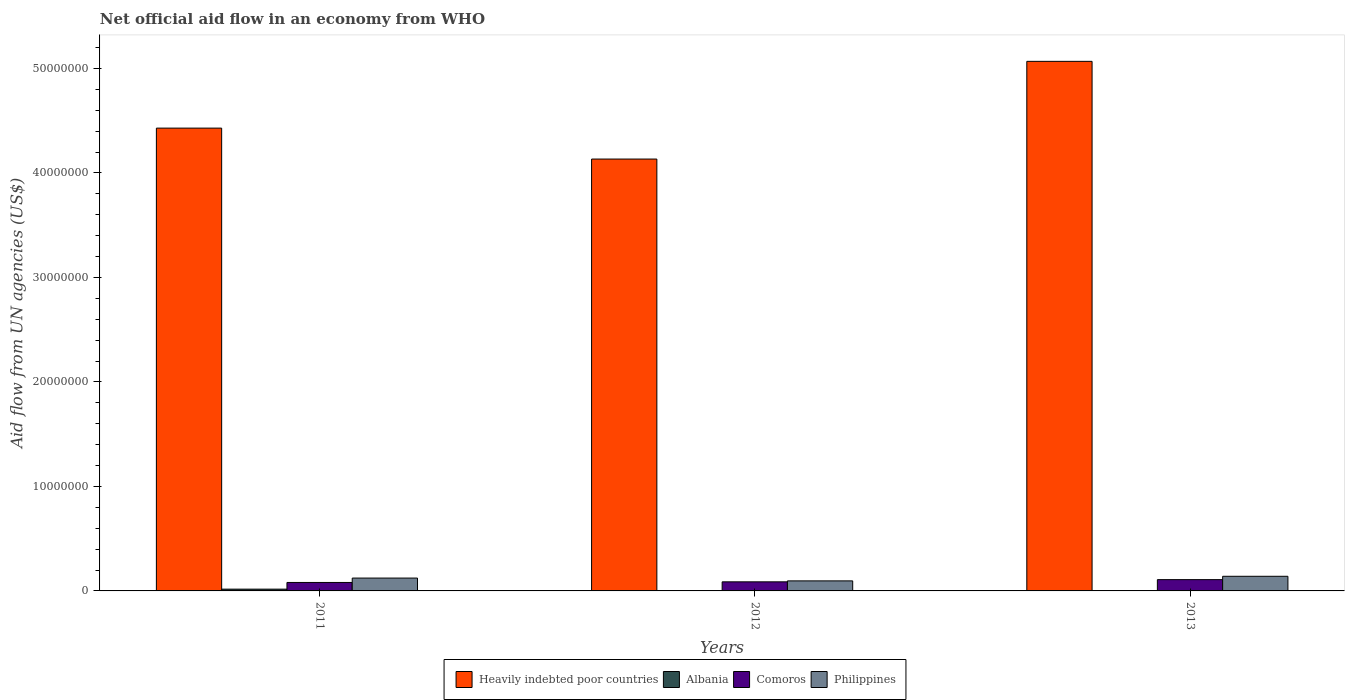How many different coloured bars are there?
Offer a very short reply. 4. How many groups of bars are there?
Offer a very short reply. 3. Are the number of bars on each tick of the X-axis equal?
Keep it short and to the point. Yes. How many bars are there on the 1st tick from the left?
Provide a short and direct response. 4. What is the label of the 3rd group of bars from the left?
Provide a short and direct response. 2013. What is the net official aid flow in Heavily indebted poor countries in 2013?
Offer a terse response. 5.07e+07. Across all years, what is the maximum net official aid flow in Heavily indebted poor countries?
Keep it short and to the point. 5.07e+07. Across all years, what is the minimum net official aid flow in Albania?
Offer a very short reply. 10000. In which year was the net official aid flow in Philippines maximum?
Provide a succinct answer. 2013. In which year was the net official aid flow in Albania minimum?
Provide a succinct answer. 2012. What is the total net official aid flow in Heavily indebted poor countries in the graph?
Offer a very short reply. 1.36e+08. What is the difference between the net official aid flow in Albania in 2011 and that in 2012?
Give a very brief answer. 1.60e+05. What is the difference between the net official aid flow in Heavily indebted poor countries in 2011 and the net official aid flow in Albania in 2013?
Your answer should be very brief. 4.43e+07. What is the average net official aid flow in Philippines per year?
Your response must be concise. 1.20e+06. In the year 2012, what is the difference between the net official aid flow in Heavily indebted poor countries and net official aid flow in Philippines?
Your answer should be very brief. 4.04e+07. In how many years, is the net official aid flow in Philippines greater than 26000000 US$?
Your answer should be very brief. 0. What is the ratio of the net official aid flow in Comoros in 2011 to that in 2013?
Keep it short and to the point. 0.75. What is the difference between the highest and the lowest net official aid flow in Comoros?
Ensure brevity in your answer.  2.70e+05. What does the 4th bar from the left in 2012 represents?
Make the answer very short. Philippines. What does the 2nd bar from the right in 2011 represents?
Your answer should be very brief. Comoros. How many bars are there?
Your answer should be compact. 12. What is the difference between two consecutive major ticks on the Y-axis?
Ensure brevity in your answer.  1.00e+07. Are the values on the major ticks of Y-axis written in scientific E-notation?
Give a very brief answer. No. Does the graph contain any zero values?
Give a very brief answer. No. Where does the legend appear in the graph?
Offer a very short reply. Bottom center. How are the legend labels stacked?
Offer a very short reply. Horizontal. What is the title of the graph?
Keep it short and to the point. Net official aid flow in an economy from WHO. What is the label or title of the Y-axis?
Offer a terse response. Aid flow from UN agencies (US$). What is the Aid flow from UN agencies (US$) of Heavily indebted poor countries in 2011?
Give a very brief answer. 4.43e+07. What is the Aid flow from UN agencies (US$) of Comoros in 2011?
Your answer should be very brief. 8.10e+05. What is the Aid flow from UN agencies (US$) in Philippines in 2011?
Provide a succinct answer. 1.23e+06. What is the Aid flow from UN agencies (US$) in Heavily indebted poor countries in 2012?
Keep it short and to the point. 4.13e+07. What is the Aid flow from UN agencies (US$) of Comoros in 2012?
Your response must be concise. 8.70e+05. What is the Aid flow from UN agencies (US$) of Philippines in 2012?
Make the answer very short. 9.60e+05. What is the Aid flow from UN agencies (US$) of Heavily indebted poor countries in 2013?
Ensure brevity in your answer.  5.07e+07. What is the Aid flow from UN agencies (US$) of Albania in 2013?
Your answer should be very brief. 3.00e+04. What is the Aid flow from UN agencies (US$) of Comoros in 2013?
Your answer should be compact. 1.08e+06. What is the Aid flow from UN agencies (US$) of Philippines in 2013?
Provide a succinct answer. 1.40e+06. Across all years, what is the maximum Aid flow from UN agencies (US$) in Heavily indebted poor countries?
Provide a succinct answer. 5.07e+07. Across all years, what is the maximum Aid flow from UN agencies (US$) of Albania?
Make the answer very short. 1.70e+05. Across all years, what is the maximum Aid flow from UN agencies (US$) in Comoros?
Ensure brevity in your answer.  1.08e+06. Across all years, what is the maximum Aid flow from UN agencies (US$) in Philippines?
Ensure brevity in your answer.  1.40e+06. Across all years, what is the minimum Aid flow from UN agencies (US$) of Heavily indebted poor countries?
Offer a very short reply. 4.13e+07. Across all years, what is the minimum Aid flow from UN agencies (US$) in Comoros?
Offer a very short reply. 8.10e+05. Across all years, what is the minimum Aid flow from UN agencies (US$) of Philippines?
Offer a very short reply. 9.60e+05. What is the total Aid flow from UN agencies (US$) in Heavily indebted poor countries in the graph?
Your answer should be compact. 1.36e+08. What is the total Aid flow from UN agencies (US$) in Albania in the graph?
Keep it short and to the point. 2.10e+05. What is the total Aid flow from UN agencies (US$) in Comoros in the graph?
Make the answer very short. 2.76e+06. What is the total Aid flow from UN agencies (US$) of Philippines in the graph?
Offer a very short reply. 3.59e+06. What is the difference between the Aid flow from UN agencies (US$) of Heavily indebted poor countries in 2011 and that in 2012?
Provide a succinct answer. 2.96e+06. What is the difference between the Aid flow from UN agencies (US$) in Albania in 2011 and that in 2012?
Give a very brief answer. 1.60e+05. What is the difference between the Aid flow from UN agencies (US$) of Comoros in 2011 and that in 2012?
Give a very brief answer. -6.00e+04. What is the difference between the Aid flow from UN agencies (US$) of Heavily indebted poor countries in 2011 and that in 2013?
Offer a terse response. -6.39e+06. What is the difference between the Aid flow from UN agencies (US$) in Albania in 2011 and that in 2013?
Your answer should be very brief. 1.40e+05. What is the difference between the Aid flow from UN agencies (US$) in Heavily indebted poor countries in 2012 and that in 2013?
Offer a very short reply. -9.35e+06. What is the difference between the Aid flow from UN agencies (US$) in Albania in 2012 and that in 2013?
Keep it short and to the point. -2.00e+04. What is the difference between the Aid flow from UN agencies (US$) of Philippines in 2012 and that in 2013?
Offer a very short reply. -4.40e+05. What is the difference between the Aid flow from UN agencies (US$) of Heavily indebted poor countries in 2011 and the Aid flow from UN agencies (US$) of Albania in 2012?
Offer a very short reply. 4.43e+07. What is the difference between the Aid flow from UN agencies (US$) in Heavily indebted poor countries in 2011 and the Aid flow from UN agencies (US$) in Comoros in 2012?
Your answer should be very brief. 4.34e+07. What is the difference between the Aid flow from UN agencies (US$) of Heavily indebted poor countries in 2011 and the Aid flow from UN agencies (US$) of Philippines in 2012?
Keep it short and to the point. 4.33e+07. What is the difference between the Aid flow from UN agencies (US$) in Albania in 2011 and the Aid flow from UN agencies (US$) in Comoros in 2012?
Provide a short and direct response. -7.00e+05. What is the difference between the Aid flow from UN agencies (US$) of Albania in 2011 and the Aid flow from UN agencies (US$) of Philippines in 2012?
Your response must be concise. -7.90e+05. What is the difference between the Aid flow from UN agencies (US$) of Heavily indebted poor countries in 2011 and the Aid flow from UN agencies (US$) of Albania in 2013?
Provide a succinct answer. 4.43e+07. What is the difference between the Aid flow from UN agencies (US$) in Heavily indebted poor countries in 2011 and the Aid flow from UN agencies (US$) in Comoros in 2013?
Offer a very short reply. 4.32e+07. What is the difference between the Aid flow from UN agencies (US$) of Heavily indebted poor countries in 2011 and the Aid flow from UN agencies (US$) of Philippines in 2013?
Ensure brevity in your answer.  4.29e+07. What is the difference between the Aid flow from UN agencies (US$) of Albania in 2011 and the Aid flow from UN agencies (US$) of Comoros in 2013?
Your answer should be very brief. -9.10e+05. What is the difference between the Aid flow from UN agencies (US$) of Albania in 2011 and the Aid flow from UN agencies (US$) of Philippines in 2013?
Provide a short and direct response. -1.23e+06. What is the difference between the Aid flow from UN agencies (US$) in Comoros in 2011 and the Aid flow from UN agencies (US$) in Philippines in 2013?
Keep it short and to the point. -5.90e+05. What is the difference between the Aid flow from UN agencies (US$) in Heavily indebted poor countries in 2012 and the Aid flow from UN agencies (US$) in Albania in 2013?
Offer a terse response. 4.13e+07. What is the difference between the Aid flow from UN agencies (US$) of Heavily indebted poor countries in 2012 and the Aid flow from UN agencies (US$) of Comoros in 2013?
Offer a very short reply. 4.02e+07. What is the difference between the Aid flow from UN agencies (US$) in Heavily indebted poor countries in 2012 and the Aid flow from UN agencies (US$) in Philippines in 2013?
Offer a very short reply. 3.99e+07. What is the difference between the Aid flow from UN agencies (US$) in Albania in 2012 and the Aid flow from UN agencies (US$) in Comoros in 2013?
Ensure brevity in your answer.  -1.07e+06. What is the difference between the Aid flow from UN agencies (US$) of Albania in 2012 and the Aid flow from UN agencies (US$) of Philippines in 2013?
Provide a short and direct response. -1.39e+06. What is the difference between the Aid flow from UN agencies (US$) of Comoros in 2012 and the Aid flow from UN agencies (US$) of Philippines in 2013?
Ensure brevity in your answer.  -5.30e+05. What is the average Aid flow from UN agencies (US$) in Heavily indebted poor countries per year?
Make the answer very short. 4.54e+07. What is the average Aid flow from UN agencies (US$) of Albania per year?
Provide a short and direct response. 7.00e+04. What is the average Aid flow from UN agencies (US$) of Comoros per year?
Keep it short and to the point. 9.20e+05. What is the average Aid flow from UN agencies (US$) in Philippines per year?
Give a very brief answer. 1.20e+06. In the year 2011, what is the difference between the Aid flow from UN agencies (US$) of Heavily indebted poor countries and Aid flow from UN agencies (US$) of Albania?
Provide a short and direct response. 4.41e+07. In the year 2011, what is the difference between the Aid flow from UN agencies (US$) of Heavily indebted poor countries and Aid flow from UN agencies (US$) of Comoros?
Ensure brevity in your answer.  4.35e+07. In the year 2011, what is the difference between the Aid flow from UN agencies (US$) of Heavily indebted poor countries and Aid flow from UN agencies (US$) of Philippines?
Provide a short and direct response. 4.31e+07. In the year 2011, what is the difference between the Aid flow from UN agencies (US$) of Albania and Aid flow from UN agencies (US$) of Comoros?
Your response must be concise. -6.40e+05. In the year 2011, what is the difference between the Aid flow from UN agencies (US$) in Albania and Aid flow from UN agencies (US$) in Philippines?
Offer a very short reply. -1.06e+06. In the year 2011, what is the difference between the Aid flow from UN agencies (US$) in Comoros and Aid flow from UN agencies (US$) in Philippines?
Your answer should be very brief. -4.20e+05. In the year 2012, what is the difference between the Aid flow from UN agencies (US$) in Heavily indebted poor countries and Aid flow from UN agencies (US$) in Albania?
Keep it short and to the point. 4.13e+07. In the year 2012, what is the difference between the Aid flow from UN agencies (US$) in Heavily indebted poor countries and Aid flow from UN agencies (US$) in Comoros?
Provide a short and direct response. 4.05e+07. In the year 2012, what is the difference between the Aid flow from UN agencies (US$) in Heavily indebted poor countries and Aid flow from UN agencies (US$) in Philippines?
Ensure brevity in your answer.  4.04e+07. In the year 2012, what is the difference between the Aid flow from UN agencies (US$) of Albania and Aid flow from UN agencies (US$) of Comoros?
Give a very brief answer. -8.60e+05. In the year 2012, what is the difference between the Aid flow from UN agencies (US$) in Albania and Aid flow from UN agencies (US$) in Philippines?
Your answer should be compact. -9.50e+05. In the year 2012, what is the difference between the Aid flow from UN agencies (US$) of Comoros and Aid flow from UN agencies (US$) of Philippines?
Offer a very short reply. -9.00e+04. In the year 2013, what is the difference between the Aid flow from UN agencies (US$) of Heavily indebted poor countries and Aid flow from UN agencies (US$) of Albania?
Your answer should be very brief. 5.06e+07. In the year 2013, what is the difference between the Aid flow from UN agencies (US$) in Heavily indebted poor countries and Aid flow from UN agencies (US$) in Comoros?
Ensure brevity in your answer.  4.96e+07. In the year 2013, what is the difference between the Aid flow from UN agencies (US$) in Heavily indebted poor countries and Aid flow from UN agencies (US$) in Philippines?
Offer a terse response. 4.93e+07. In the year 2013, what is the difference between the Aid flow from UN agencies (US$) in Albania and Aid flow from UN agencies (US$) in Comoros?
Provide a short and direct response. -1.05e+06. In the year 2013, what is the difference between the Aid flow from UN agencies (US$) in Albania and Aid flow from UN agencies (US$) in Philippines?
Offer a terse response. -1.37e+06. In the year 2013, what is the difference between the Aid flow from UN agencies (US$) of Comoros and Aid flow from UN agencies (US$) of Philippines?
Make the answer very short. -3.20e+05. What is the ratio of the Aid flow from UN agencies (US$) in Heavily indebted poor countries in 2011 to that in 2012?
Keep it short and to the point. 1.07. What is the ratio of the Aid flow from UN agencies (US$) of Comoros in 2011 to that in 2012?
Your answer should be compact. 0.93. What is the ratio of the Aid flow from UN agencies (US$) in Philippines in 2011 to that in 2012?
Your response must be concise. 1.28. What is the ratio of the Aid flow from UN agencies (US$) in Heavily indebted poor countries in 2011 to that in 2013?
Your answer should be compact. 0.87. What is the ratio of the Aid flow from UN agencies (US$) of Albania in 2011 to that in 2013?
Offer a terse response. 5.67. What is the ratio of the Aid flow from UN agencies (US$) of Comoros in 2011 to that in 2013?
Offer a very short reply. 0.75. What is the ratio of the Aid flow from UN agencies (US$) of Philippines in 2011 to that in 2013?
Offer a terse response. 0.88. What is the ratio of the Aid flow from UN agencies (US$) of Heavily indebted poor countries in 2012 to that in 2013?
Your answer should be very brief. 0.82. What is the ratio of the Aid flow from UN agencies (US$) of Albania in 2012 to that in 2013?
Ensure brevity in your answer.  0.33. What is the ratio of the Aid flow from UN agencies (US$) in Comoros in 2012 to that in 2013?
Your answer should be compact. 0.81. What is the ratio of the Aid flow from UN agencies (US$) in Philippines in 2012 to that in 2013?
Keep it short and to the point. 0.69. What is the difference between the highest and the second highest Aid flow from UN agencies (US$) of Heavily indebted poor countries?
Offer a terse response. 6.39e+06. What is the difference between the highest and the second highest Aid flow from UN agencies (US$) of Albania?
Ensure brevity in your answer.  1.40e+05. What is the difference between the highest and the second highest Aid flow from UN agencies (US$) in Philippines?
Provide a short and direct response. 1.70e+05. What is the difference between the highest and the lowest Aid flow from UN agencies (US$) of Heavily indebted poor countries?
Offer a very short reply. 9.35e+06. What is the difference between the highest and the lowest Aid flow from UN agencies (US$) of Albania?
Your answer should be compact. 1.60e+05. What is the difference between the highest and the lowest Aid flow from UN agencies (US$) in Philippines?
Your answer should be compact. 4.40e+05. 